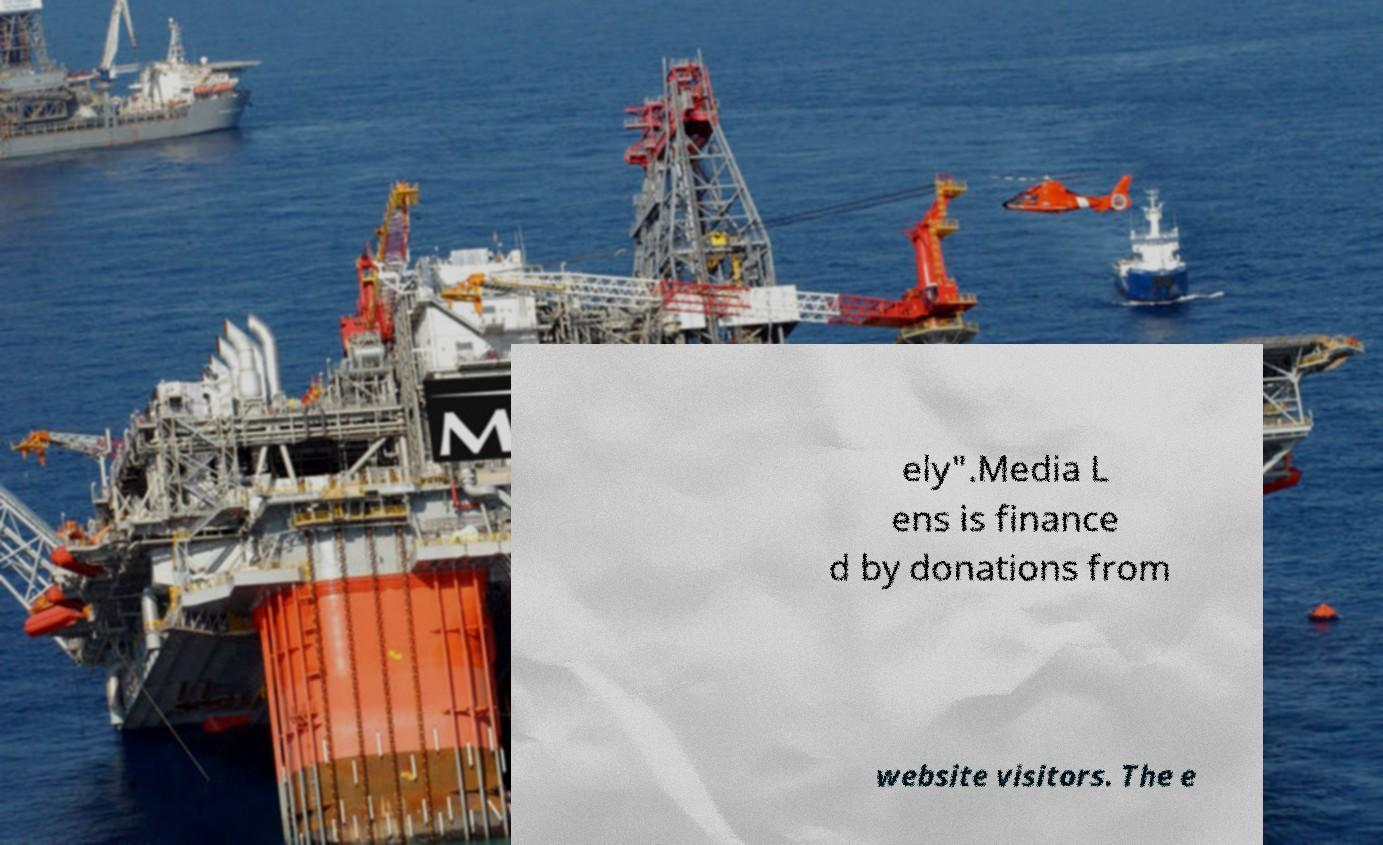For documentation purposes, I need the text within this image transcribed. Could you provide that? ely".Media L ens is finance d by donations from website visitors. The e 